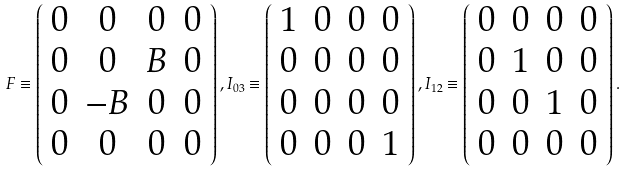Convert formula to latex. <formula><loc_0><loc_0><loc_500><loc_500>F \equiv \left ( \begin{array} { * { 4 } { c } } 0 & 0 & 0 & 0 \\ 0 & 0 & B & 0 \\ 0 & - B & 0 & 0 \\ 0 & 0 & 0 & 0 \end{array} \right ) , { I _ { 0 3 } } \equiv \left ( \begin{array} { * { 4 } { c } } 1 & 0 & 0 & 0 \\ 0 & 0 & 0 & 0 \\ 0 & 0 & 0 & 0 \\ 0 & 0 & 0 & 1 \end{array} \right ) , { I _ { 1 2 } } \equiv \left ( \begin{array} { * { 4 } { c } } 0 & 0 & 0 & 0 \\ 0 & 1 & 0 & 0 \\ 0 & 0 & 1 & 0 \\ 0 & 0 & 0 & 0 \end{array} \right ) . \\</formula> 